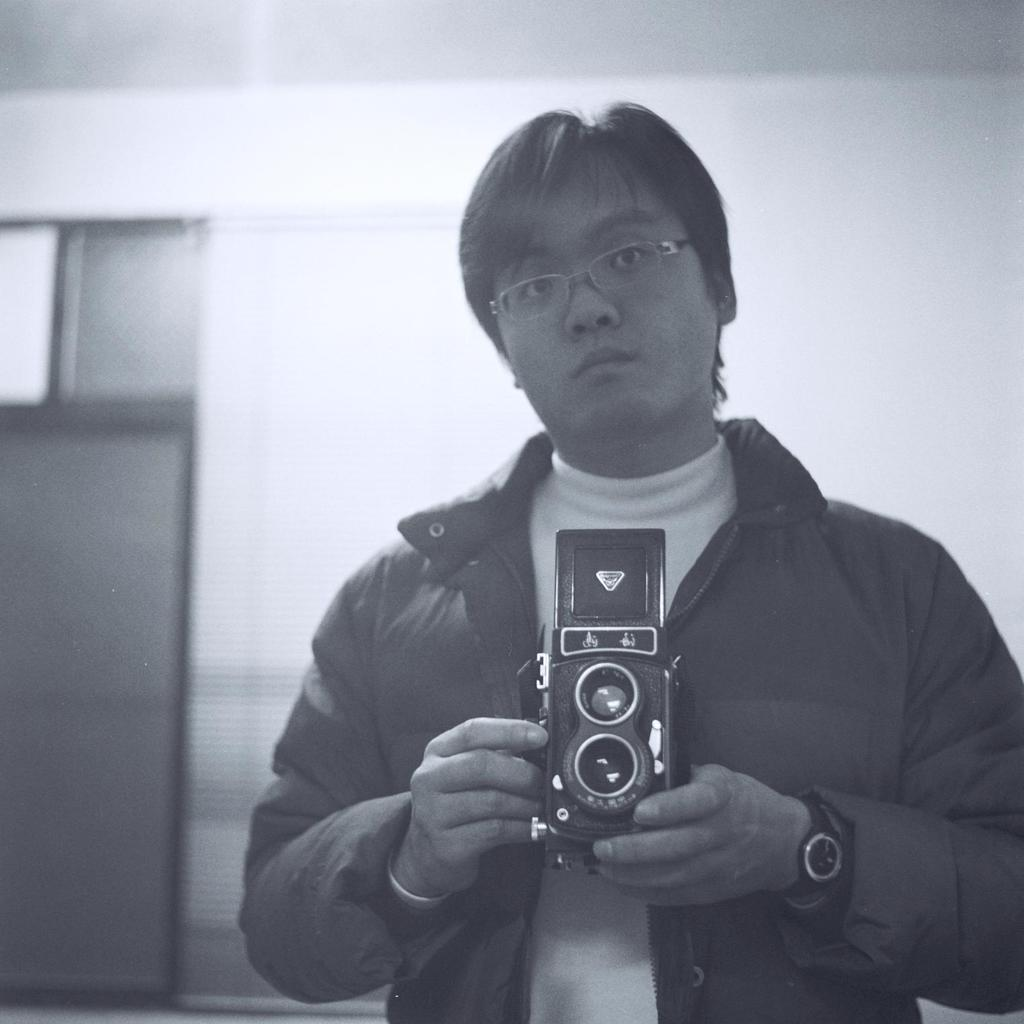What is the main subject of the image? There is a person standing in the center of the image. What is the person wearing? The person is wearing a coat. What is the person holding in his hand? The person is holding a camera in his hand. What type of fact can be seen in the image? There is no fact present in the image; it features a person standing in the center, wearing a coat, and holding a camera. Is the person's sister visible in the image? There is no mention of a sister in the image, and no other person is visible besides the one standing in the center. 